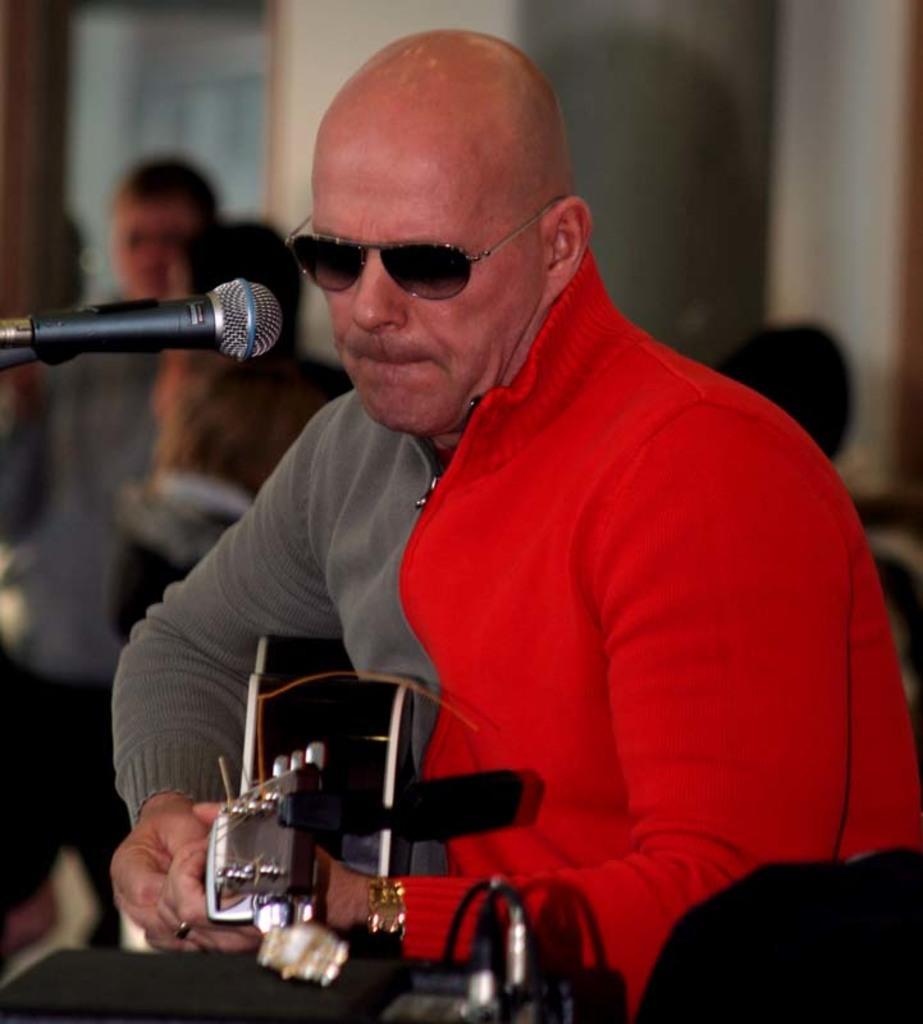How would you summarize this image in a sentence or two? In this picture there is a person sitting and playing guitar. In the foreground there is a device. On the left side of the image there is a microphone. At the back there are group of people and there is a wall. 